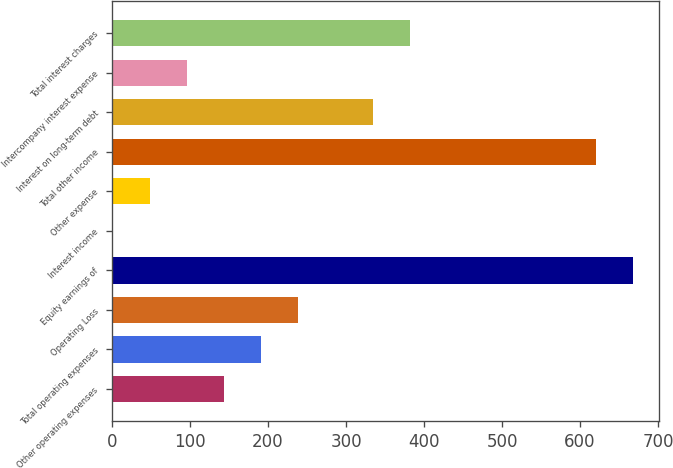<chart> <loc_0><loc_0><loc_500><loc_500><bar_chart><fcel>Other operating expenses<fcel>Total operating expenses<fcel>Operating Loss<fcel>Equity earnings of<fcel>Interest income<fcel>Other expense<fcel>Total other income<fcel>Interest on long-term debt<fcel>Intercompany interest expense<fcel>Total interest charges<nl><fcel>143.8<fcel>191.4<fcel>239<fcel>667.4<fcel>1<fcel>48.6<fcel>619.8<fcel>334.2<fcel>96.2<fcel>381.8<nl></chart> 